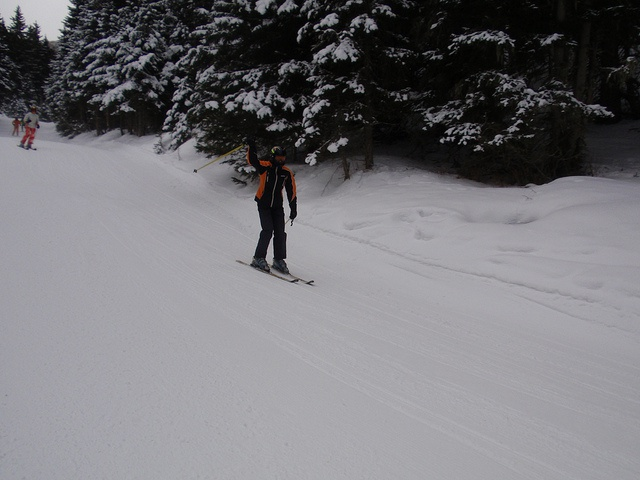Describe the objects in this image and their specific colors. I can see people in lightgray, black, maroon, darkgray, and gray tones, people in lightgray, gray, maroon, black, and purple tones, people in lightgray, gray, maroon, black, and purple tones, skis in lightgray, gray, navy, and purple tones, and people in black, purple, navy, and lightgray tones in this image. 